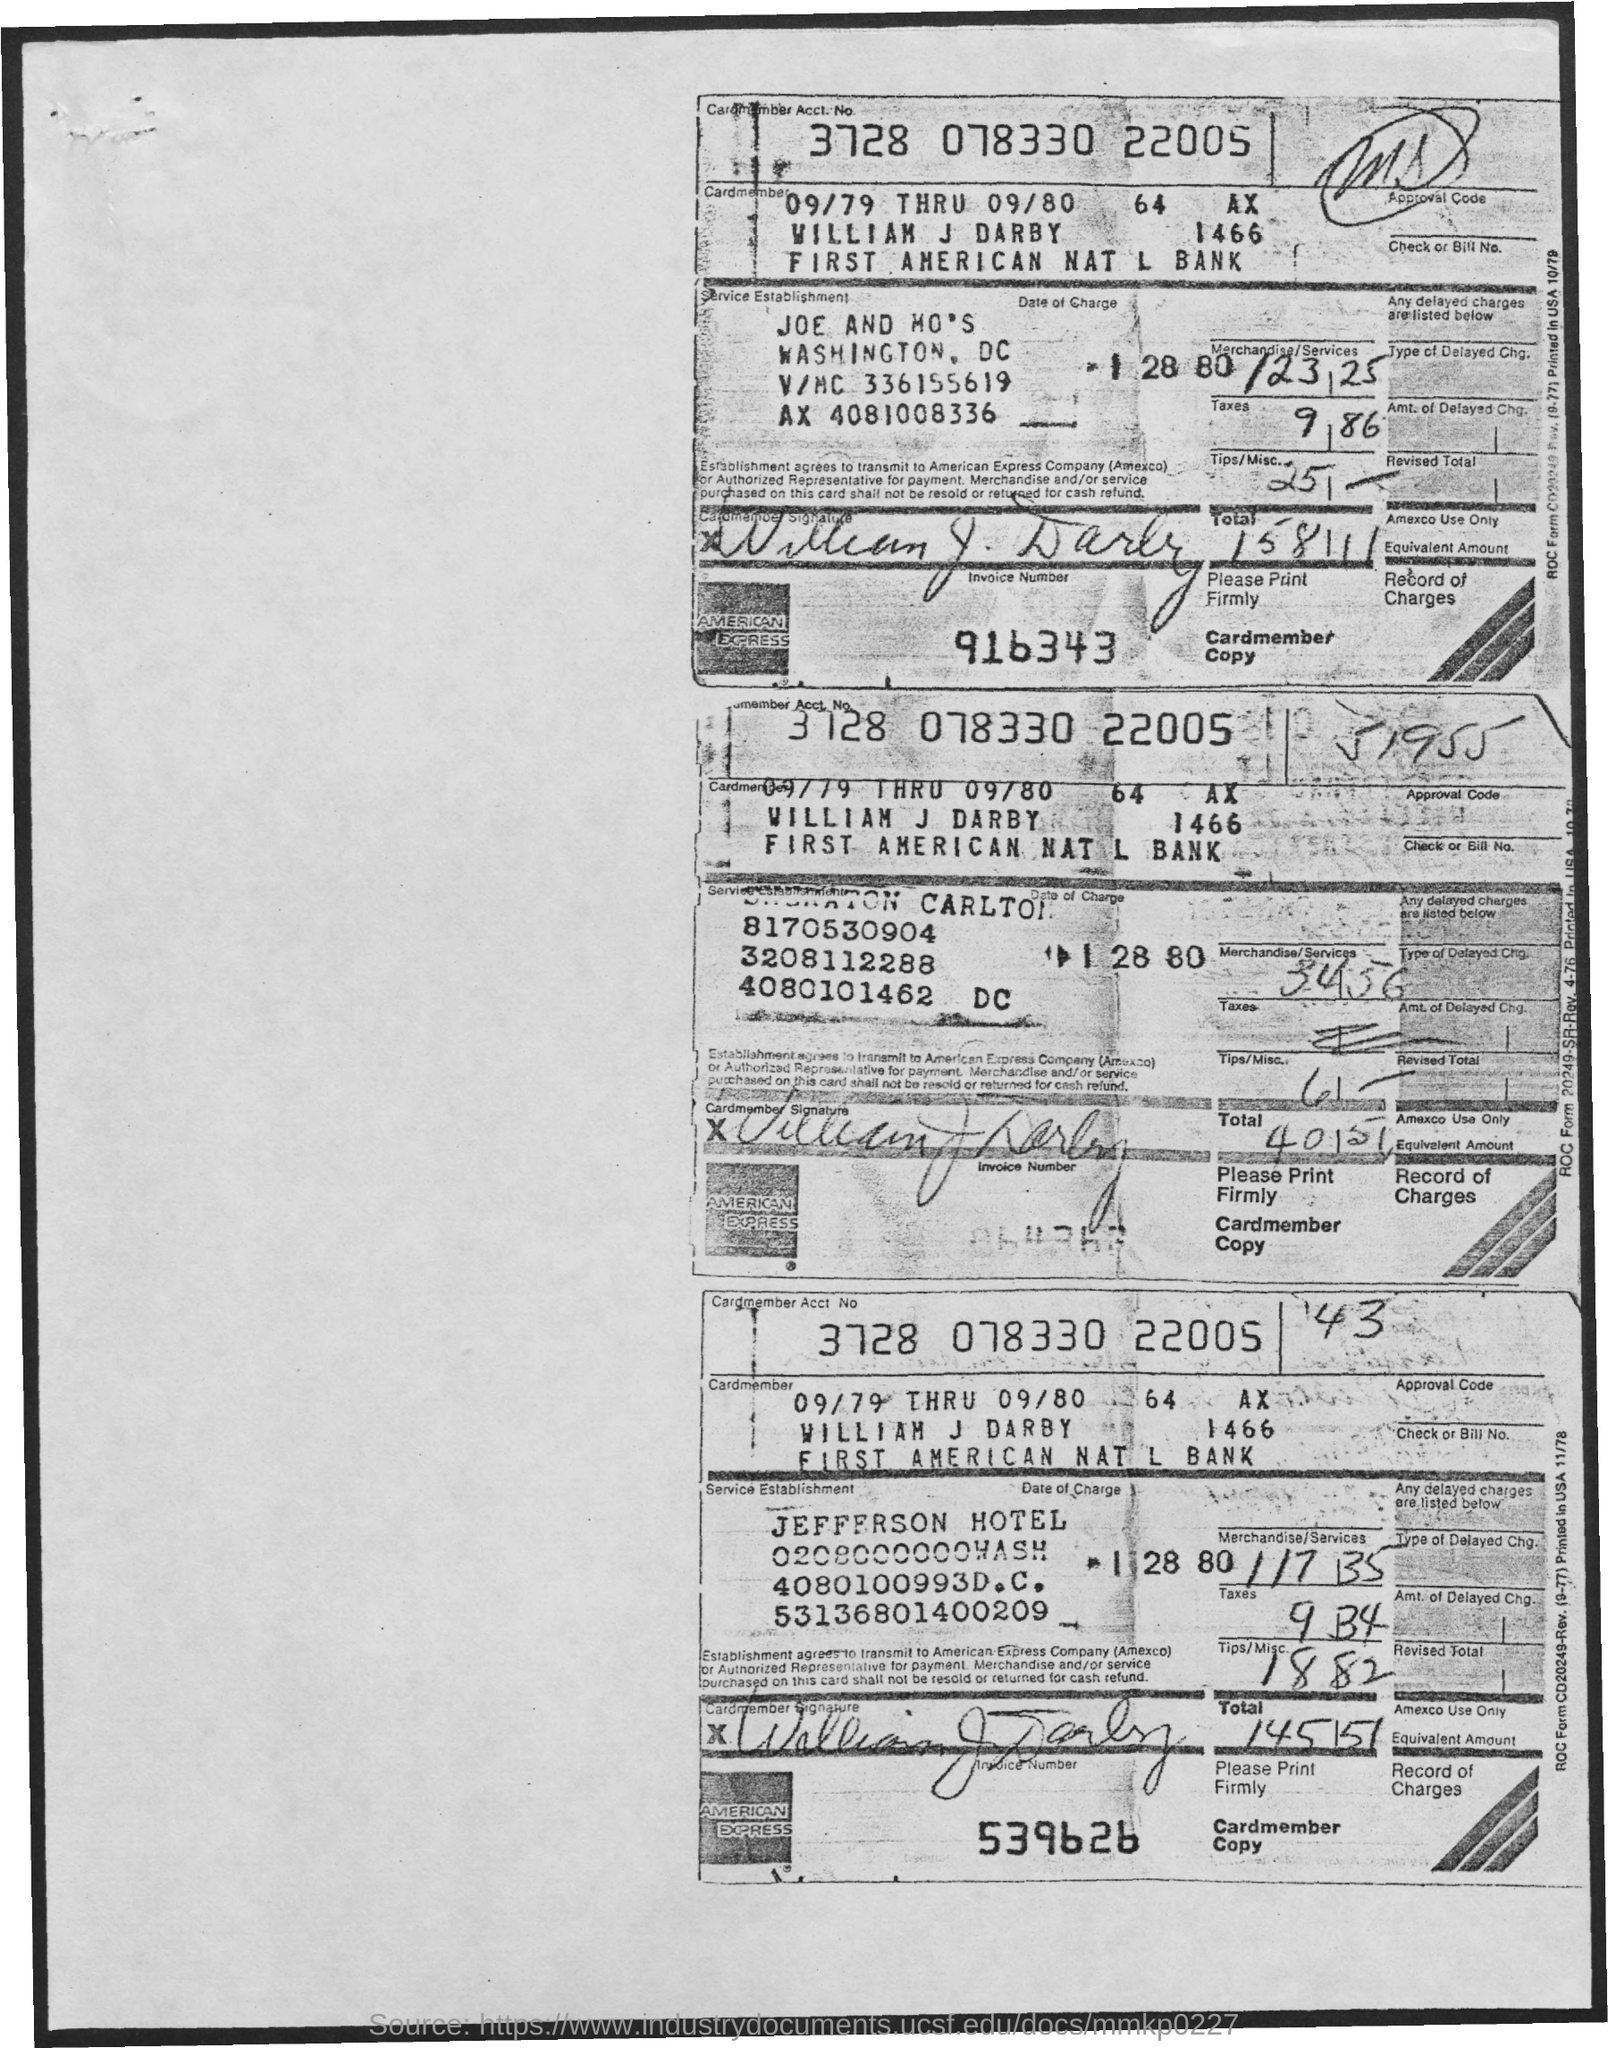List a handful of essential elements in this visual. The Cardmember Account Number is 3728 078330 22005. 